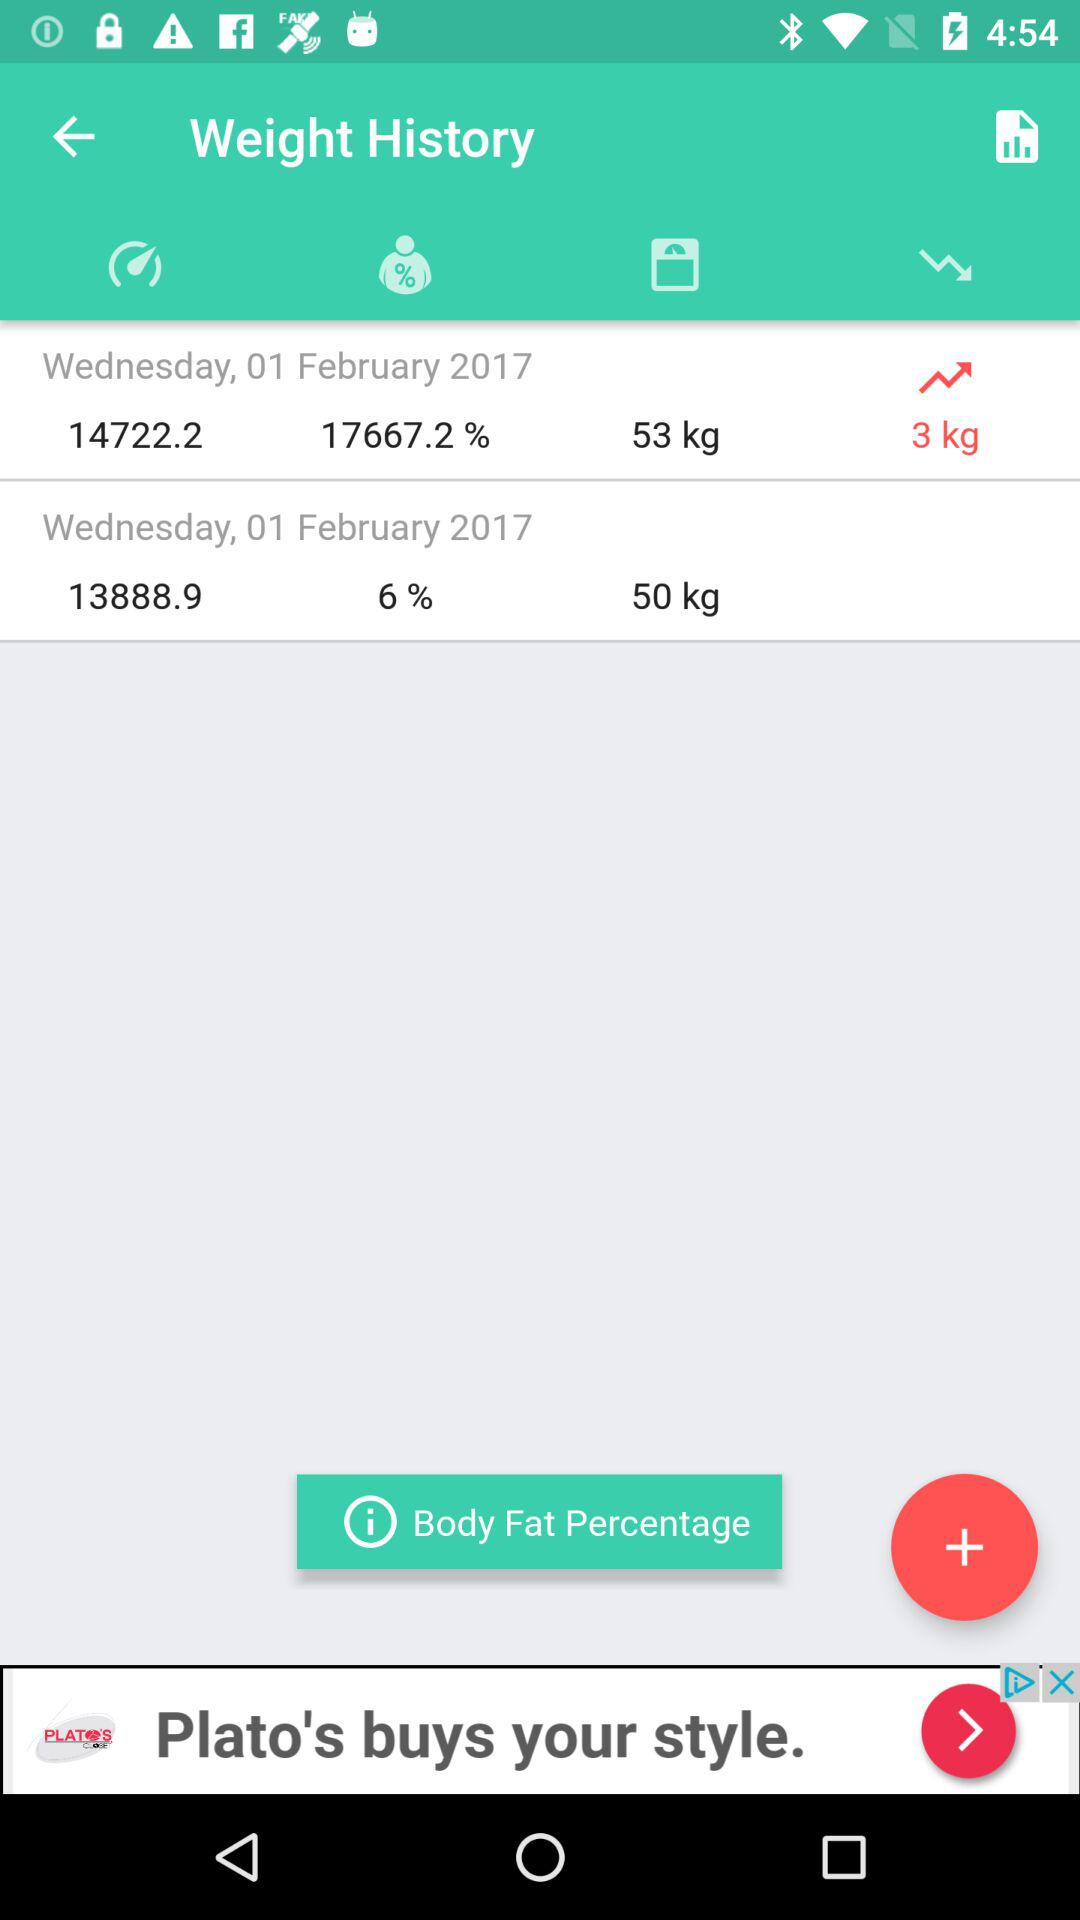What is the difference in weight between the two entries?
Answer the question using a single word or phrase. 3 kg 